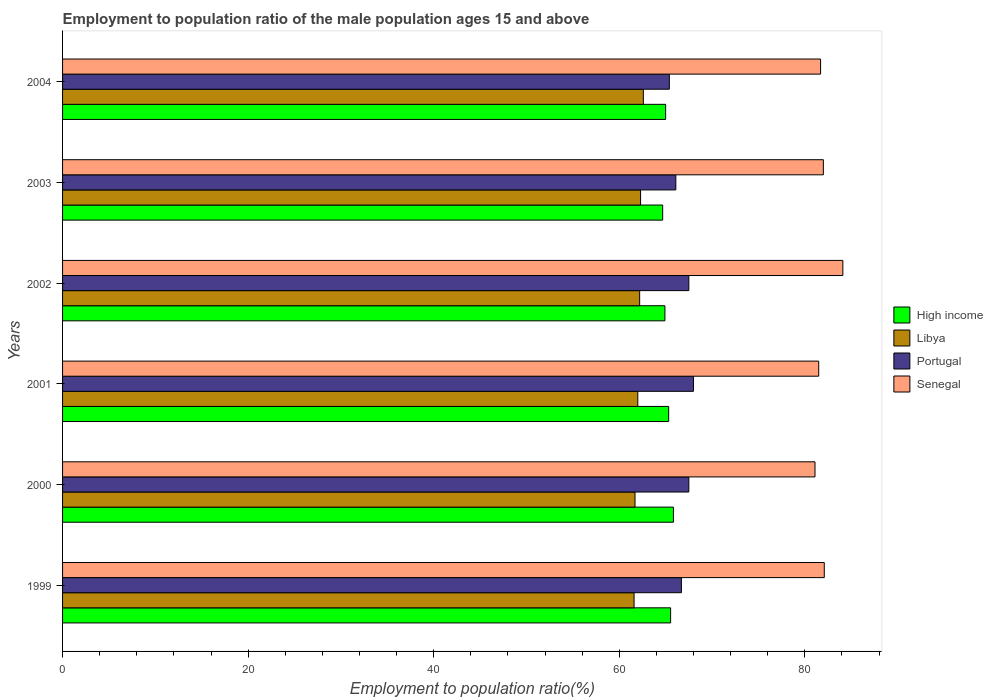How many different coloured bars are there?
Provide a succinct answer. 4. Are the number of bars on each tick of the Y-axis equal?
Make the answer very short. Yes. How many bars are there on the 3rd tick from the top?
Keep it short and to the point. 4. What is the label of the 6th group of bars from the top?
Your response must be concise. 1999. In how many cases, is the number of bars for a given year not equal to the number of legend labels?
Keep it short and to the point. 0. What is the employment to population ratio in Senegal in 2000?
Provide a short and direct response. 81.1. Across all years, what is the maximum employment to population ratio in High income?
Offer a very short reply. 65.84. Across all years, what is the minimum employment to population ratio in Senegal?
Give a very brief answer. 81.1. In which year was the employment to population ratio in Portugal maximum?
Give a very brief answer. 2001. In which year was the employment to population ratio in Libya minimum?
Your response must be concise. 1999. What is the total employment to population ratio in Libya in the graph?
Provide a short and direct response. 372.4. What is the difference between the employment to population ratio in High income in 2002 and that in 2003?
Keep it short and to the point. 0.24. What is the difference between the employment to population ratio in Senegal in 1999 and the employment to population ratio in Portugal in 2003?
Keep it short and to the point. 16. What is the average employment to population ratio in Senegal per year?
Give a very brief answer. 82.08. In the year 2001, what is the difference between the employment to population ratio in Portugal and employment to population ratio in High income?
Provide a short and direct response. 2.67. What is the ratio of the employment to population ratio in High income in 1999 to that in 2002?
Provide a succinct answer. 1.01. Is the difference between the employment to population ratio in Portugal in 1999 and 2001 greater than the difference between the employment to population ratio in High income in 1999 and 2001?
Make the answer very short. No. What is the difference between the highest and the second highest employment to population ratio in Libya?
Your answer should be compact. 0.3. What is the difference between the highest and the lowest employment to population ratio in Portugal?
Make the answer very short. 2.6. Is the sum of the employment to population ratio in Portugal in 2001 and 2004 greater than the maximum employment to population ratio in Libya across all years?
Your answer should be compact. Yes. Is it the case that in every year, the sum of the employment to population ratio in High income and employment to population ratio in Portugal is greater than the sum of employment to population ratio in Libya and employment to population ratio in Senegal?
Ensure brevity in your answer.  No. Are all the bars in the graph horizontal?
Keep it short and to the point. Yes. How many years are there in the graph?
Your answer should be very brief. 6. What is the difference between two consecutive major ticks on the X-axis?
Provide a short and direct response. 20. Does the graph contain grids?
Keep it short and to the point. No. How many legend labels are there?
Provide a succinct answer. 4. What is the title of the graph?
Offer a terse response. Employment to population ratio of the male population ages 15 and above. Does "Niger" appear as one of the legend labels in the graph?
Give a very brief answer. No. What is the label or title of the X-axis?
Offer a very short reply. Employment to population ratio(%). What is the label or title of the Y-axis?
Your response must be concise. Years. What is the Employment to population ratio(%) in High income in 1999?
Provide a short and direct response. 65.54. What is the Employment to population ratio(%) in Libya in 1999?
Your response must be concise. 61.6. What is the Employment to population ratio(%) in Portugal in 1999?
Your response must be concise. 66.7. What is the Employment to population ratio(%) in Senegal in 1999?
Offer a very short reply. 82.1. What is the Employment to population ratio(%) of High income in 2000?
Provide a short and direct response. 65.84. What is the Employment to population ratio(%) in Libya in 2000?
Offer a very short reply. 61.7. What is the Employment to population ratio(%) in Portugal in 2000?
Provide a succinct answer. 67.5. What is the Employment to population ratio(%) in Senegal in 2000?
Give a very brief answer. 81.1. What is the Employment to population ratio(%) of High income in 2001?
Your answer should be compact. 65.33. What is the Employment to population ratio(%) in Libya in 2001?
Keep it short and to the point. 62. What is the Employment to population ratio(%) of Senegal in 2001?
Keep it short and to the point. 81.5. What is the Employment to population ratio(%) in High income in 2002?
Your answer should be very brief. 64.92. What is the Employment to population ratio(%) in Libya in 2002?
Your response must be concise. 62.2. What is the Employment to population ratio(%) in Portugal in 2002?
Give a very brief answer. 67.5. What is the Employment to population ratio(%) in Senegal in 2002?
Offer a very short reply. 84.1. What is the Employment to population ratio(%) of High income in 2003?
Give a very brief answer. 64.68. What is the Employment to population ratio(%) of Libya in 2003?
Keep it short and to the point. 62.3. What is the Employment to population ratio(%) in Portugal in 2003?
Offer a very short reply. 66.1. What is the Employment to population ratio(%) of Senegal in 2003?
Give a very brief answer. 82. What is the Employment to population ratio(%) of High income in 2004?
Your answer should be very brief. 65. What is the Employment to population ratio(%) in Libya in 2004?
Your answer should be very brief. 62.6. What is the Employment to population ratio(%) in Portugal in 2004?
Provide a short and direct response. 65.4. What is the Employment to population ratio(%) in Senegal in 2004?
Give a very brief answer. 81.7. Across all years, what is the maximum Employment to population ratio(%) in High income?
Your response must be concise. 65.84. Across all years, what is the maximum Employment to population ratio(%) of Libya?
Provide a short and direct response. 62.6. Across all years, what is the maximum Employment to population ratio(%) of Senegal?
Your answer should be compact. 84.1. Across all years, what is the minimum Employment to population ratio(%) of High income?
Ensure brevity in your answer.  64.68. Across all years, what is the minimum Employment to population ratio(%) of Libya?
Your answer should be compact. 61.6. Across all years, what is the minimum Employment to population ratio(%) of Portugal?
Provide a succinct answer. 65.4. Across all years, what is the minimum Employment to population ratio(%) in Senegal?
Provide a short and direct response. 81.1. What is the total Employment to population ratio(%) of High income in the graph?
Keep it short and to the point. 391.31. What is the total Employment to population ratio(%) in Libya in the graph?
Keep it short and to the point. 372.4. What is the total Employment to population ratio(%) of Portugal in the graph?
Offer a very short reply. 401.2. What is the total Employment to population ratio(%) in Senegal in the graph?
Your answer should be very brief. 492.5. What is the difference between the Employment to population ratio(%) in High income in 1999 and that in 2000?
Keep it short and to the point. -0.3. What is the difference between the Employment to population ratio(%) of Portugal in 1999 and that in 2000?
Offer a terse response. -0.8. What is the difference between the Employment to population ratio(%) in High income in 1999 and that in 2001?
Your answer should be compact. 0.21. What is the difference between the Employment to population ratio(%) in High income in 1999 and that in 2002?
Provide a short and direct response. 0.61. What is the difference between the Employment to population ratio(%) in Portugal in 1999 and that in 2002?
Ensure brevity in your answer.  -0.8. What is the difference between the Employment to population ratio(%) of High income in 1999 and that in 2003?
Your response must be concise. 0.86. What is the difference between the Employment to population ratio(%) of Libya in 1999 and that in 2003?
Give a very brief answer. -0.7. What is the difference between the Employment to population ratio(%) of Senegal in 1999 and that in 2003?
Your answer should be very brief. 0.1. What is the difference between the Employment to population ratio(%) in High income in 1999 and that in 2004?
Provide a succinct answer. 0.54. What is the difference between the Employment to population ratio(%) in Portugal in 1999 and that in 2004?
Ensure brevity in your answer.  1.3. What is the difference between the Employment to population ratio(%) in High income in 2000 and that in 2001?
Offer a very short reply. 0.51. What is the difference between the Employment to population ratio(%) of Portugal in 2000 and that in 2001?
Offer a very short reply. -0.5. What is the difference between the Employment to population ratio(%) of Senegal in 2000 and that in 2001?
Keep it short and to the point. -0.4. What is the difference between the Employment to population ratio(%) of High income in 2000 and that in 2002?
Offer a terse response. 0.92. What is the difference between the Employment to population ratio(%) of High income in 2000 and that in 2003?
Provide a succinct answer. 1.16. What is the difference between the Employment to population ratio(%) in Senegal in 2000 and that in 2003?
Ensure brevity in your answer.  -0.9. What is the difference between the Employment to population ratio(%) in High income in 2000 and that in 2004?
Give a very brief answer. 0.84. What is the difference between the Employment to population ratio(%) of Senegal in 2000 and that in 2004?
Your answer should be very brief. -0.6. What is the difference between the Employment to population ratio(%) in High income in 2001 and that in 2002?
Offer a very short reply. 0.4. What is the difference between the Employment to population ratio(%) in Senegal in 2001 and that in 2002?
Your answer should be compact. -2.6. What is the difference between the Employment to population ratio(%) of High income in 2001 and that in 2003?
Keep it short and to the point. 0.65. What is the difference between the Employment to population ratio(%) in Libya in 2001 and that in 2003?
Make the answer very short. -0.3. What is the difference between the Employment to population ratio(%) of High income in 2001 and that in 2004?
Offer a terse response. 0.33. What is the difference between the Employment to population ratio(%) of Portugal in 2001 and that in 2004?
Offer a very short reply. 2.6. What is the difference between the Employment to population ratio(%) of High income in 2002 and that in 2003?
Your response must be concise. 0.24. What is the difference between the Employment to population ratio(%) in Libya in 2002 and that in 2003?
Keep it short and to the point. -0.1. What is the difference between the Employment to population ratio(%) in Senegal in 2002 and that in 2003?
Your answer should be compact. 2.1. What is the difference between the Employment to population ratio(%) in High income in 2002 and that in 2004?
Your answer should be very brief. -0.08. What is the difference between the Employment to population ratio(%) in Libya in 2002 and that in 2004?
Give a very brief answer. -0.4. What is the difference between the Employment to population ratio(%) of Senegal in 2002 and that in 2004?
Give a very brief answer. 2.4. What is the difference between the Employment to population ratio(%) in High income in 2003 and that in 2004?
Your answer should be very brief. -0.32. What is the difference between the Employment to population ratio(%) of Portugal in 2003 and that in 2004?
Provide a short and direct response. 0.7. What is the difference between the Employment to population ratio(%) in Senegal in 2003 and that in 2004?
Offer a terse response. 0.3. What is the difference between the Employment to population ratio(%) of High income in 1999 and the Employment to population ratio(%) of Libya in 2000?
Ensure brevity in your answer.  3.84. What is the difference between the Employment to population ratio(%) of High income in 1999 and the Employment to population ratio(%) of Portugal in 2000?
Give a very brief answer. -1.96. What is the difference between the Employment to population ratio(%) in High income in 1999 and the Employment to population ratio(%) in Senegal in 2000?
Make the answer very short. -15.56. What is the difference between the Employment to population ratio(%) in Libya in 1999 and the Employment to population ratio(%) in Senegal in 2000?
Your answer should be compact. -19.5. What is the difference between the Employment to population ratio(%) of Portugal in 1999 and the Employment to population ratio(%) of Senegal in 2000?
Your answer should be compact. -14.4. What is the difference between the Employment to population ratio(%) in High income in 1999 and the Employment to population ratio(%) in Libya in 2001?
Provide a succinct answer. 3.54. What is the difference between the Employment to population ratio(%) in High income in 1999 and the Employment to population ratio(%) in Portugal in 2001?
Your answer should be compact. -2.46. What is the difference between the Employment to population ratio(%) of High income in 1999 and the Employment to population ratio(%) of Senegal in 2001?
Provide a succinct answer. -15.96. What is the difference between the Employment to population ratio(%) in Libya in 1999 and the Employment to population ratio(%) in Senegal in 2001?
Give a very brief answer. -19.9. What is the difference between the Employment to population ratio(%) in Portugal in 1999 and the Employment to population ratio(%) in Senegal in 2001?
Keep it short and to the point. -14.8. What is the difference between the Employment to population ratio(%) in High income in 1999 and the Employment to population ratio(%) in Libya in 2002?
Provide a short and direct response. 3.34. What is the difference between the Employment to population ratio(%) of High income in 1999 and the Employment to population ratio(%) of Portugal in 2002?
Offer a very short reply. -1.96. What is the difference between the Employment to population ratio(%) in High income in 1999 and the Employment to population ratio(%) in Senegal in 2002?
Offer a very short reply. -18.56. What is the difference between the Employment to population ratio(%) of Libya in 1999 and the Employment to population ratio(%) of Portugal in 2002?
Offer a very short reply. -5.9. What is the difference between the Employment to population ratio(%) of Libya in 1999 and the Employment to population ratio(%) of Senegal in 2002?
Keep it short and to the point. -22.5. What is the difference between the Employment to population ratio(%) of Portugal in 1999 and the Employment to population ratio(%) of Senegal in 2002?
Keep it short and to the point. -17.4. What is the difference between the Employment to population ratio(%) of High income in 1999 and the Employment to population ratio(%) of Libya in 2003?
Your response must be concise. 3.24. What is the difference between the Employment to population ratio(%) of High income in 1999 and the Employment to population ratio(%) of Portugal in 2003?
Ensure brevity in your answer.  -0.56. What is the difference between the Employment to population ratio(%) of High income in 1999 and the Employment to population ratio(%) of Senegal in 2003?
Keep it short and to the point. -16.46. What is the difference between the Employment to population ratio(%) of Libya in 1999 and the Employment to population ratio(%) of Senegal in 2003?
Give a very brief answer. -20.4. What is the difference between the Employment to population ratio(%) in Portugal in 1999 and the Employment to population ratio(%) in Senegal in 2003?
Offer a very short reply. -15.3. What is the difference between the Employment to population ratio(%) in High income in 1999 and the Employment to population ratio(%) in Libya in 2004?
Ensure brevity in your answer.  2.94. What is the difference between the Employment to population ratio(%) of High income in 1999 and the Employment to population ratio(%) of Portugal in 2004?
Provide a short and direct response. 0.14. What is the difference between the Employment to population ratio(%) in High income in 1999 and the Employment to population ratio(%) in Senegal in 2004?
Give a very brief answer. -16.16. What is the difference between the Employment to population ratio(%) of Libya in 1999 and the Employment to population ratio(%) of Portugal in 2004?
Offer a terse response. -3.8. What is the difference between the Employment to population ratio(%) in Libya in 1999 and the Employment to population ratio(%) in Senegal in 2004?
Make the answer very short. -20.1. What is the difference between the Employment to population ratio(%) of Portugal in 1999 and the Employment to population ratio(%) of Senegal in 2004?
Make the answer very short. -15. What is the difference between the Employment to population ratio(%) of High income in 2000 and the Employment to population ratio(%) of Libya in 2001?
Make the answer very short. 3.84. What is the difference between the Employment to population ratio(%) in High income in 2000 and the Employment to population ratio(%) in Portugal in 2001?
Offer a terse response. -2.16. What is the difference between the Employment to population ratio(%) of High income in 2000 and the Employment to population ratio(%) of Senegal in 2001?
Provide a succinct answer. -15.66. What is the difference between the Employment to population ratio(%) of Libya in 2000 and the Employment to population ratio(%) of Portugal in 2001?
Your answer should be compact. -6.3. What is the difference between the Employment to population ratio(%) in Libya in 2000 and the Employment to population ratio(%) in Senegal in 2001?
Provide a succinct answer. -19.8. What is the difference between the Employment to population ratio(%) of Portugal in 2000 and the Employment to population ratio(%) of Senegal in 2001?
Give a very brief answer. -14. What is the difference between the Employment to population ratio(%) of High income in 2000 and the Employment to population ratio(%) of Libya in 2002?
Your answer should be very brief. 3.64. What is the difference between the Employment to population ratio(%) in High income in 2000 and the Employment to population ratio(%) in Portugal in 2002?
Give a very brief answer. -1.66. What is the difference between the Employment to population ratio(%) in High income in 2000 and the Employment to population ratio(%) in Senegal in 2002?
Make the answer very short. -18.26. What is the difference between the Employment to population ratio(%) of Libya in 2000 and the Employment to population ratio(%) of Senegal in 2002?
Offer a very short reply. -22.4. What is the difference between the Employment to population ratio(%) of Portugal in 2000 and the Employment to population ratio(%) of Senegal in 2002?
Provide a succinct answer. -16.6. What is the difference between the Employment to population ratio(%) in High income in 2000 and the Employment to population ratio(%) in Libya in 2003?
Provide a succinct answer. 3.54. What is the difference between the Employment to population ratio(%) of High income in 2000 and the Employment to population ratio(%) of Portugal in 2003?
Your answer should be very brief. -0.26. What is the difference between the Employment to population ratio(%) in High income in 2000 and the Employment to population ratio(%) in Senegal in 2003?
Offer a terse response. -16.16. What is the difference between the Employment to population ratio(%) in Libya in 2000 and the Employment to population ratio(%) in Portugal in 2003?
Provide a short and direct response. -4.4. What is the difference between the Employment to population ratio(%) in Libya in 2000 and the Employment to population ratio(%) in Senegal in 2003?
Give a very brief answer. -20.3. What is the difference between the Employment to population ratio(%) of Portugal in 2000 and the Employment to population ratio(%) of Senegal in 2003?
Keep it short and to the point. -14.5. What is the difference between the Employment to population ratio(%) in High income in 2000 and the Employment to population ratio(%) in Libya in 2004?
Your response must be concise. 3.24. What is the difference between the Employment to population ratio(%) of High income in 2000 and the Employment to population ratio(%) of Portugal in 2004?
Give a very brief answer. 0.44. What is the difference between the Employment to population ratio(%) in High income in 2000 and the Employment to population ratio(%) in Senegal in 2004?
Provide a succinct answer. -15.86. What is the difference between the Employment to population ratio(%) of Portugal in 2000 and the Employment to population ratio(%) of Senegal in 2004?
Keep it short and to the point. -14.2. What is the difference between the Employment to population ratio(%) in High income in 2001 and the Employment to population ratio(%) in Libya in 2002?
Offer a terse response. 3.13. What is the difference between the Employment to population ratio(%) of High income in 2001 and the Employment to population ratio(%) of Portugal in 2002?
Ensure brevity in your answer.  -2.17. What is the difference between the Employment to population ratio(%) in High income in 2001 and the Employment to population ratio(%) in Senegal in 2002?
Your answer should be compact. -18.77. What is the difference between the Employment to population ratio(%) of Libya in 2001 and the Employment to population ratio(%) of Portugal in 2002?
Provide a succinct answer. -5.5. What is the difference between the Employment to population ratio(%) of Libya in 2001 and the Employment to population ratio(%) of Senegal in 2002?
Provide a succinct answer. -22.1. What is the difference between the Employment to population ratio(%) of Portugal in 2001 and the Employment to population ratio(%) of Senegal in 2002?
Your response must be concise. -16.1. What is the difference between the Employment to population ratio(%) in High income in 2001 and the Employment to population ratio(%) in Libya in 2003?
Ensure brevity in your answer.  3.03. What is the difference between the Employment to population ratio(%) in High income in 2001 and the Employment to population ratio(%) in Portugal in 2003?
Offer a terse response. -0.77. What is the difference between the Employment to population ratio(%) in High income in 2001 and the Employment to population ratio(%) in Senegal in 2003?
Provide a short and direct response. -16.67. What is the difference between the Employment to population ratio(%) in Libya in 2001 and the Employment to population ratio(%) in Senegal in 2003?
Your answer should be compact. -20. What is the difference between the Employment to population ratio(%) of Portugal in 2001 and the Employment to population ratio(%) of Senegal in 2003?
Ensure brevity in your answer.  -14. What is the difference between the Employment to population ratio(%) in High income in 2001 and the Employment to population ratio(%) in Libya in 2004?
Keep it short and to the point. 2.73. What is the difference between the Employment to population ratio(%) of High income in 2001 and the Employment to population ratio(%) of Portugal in 2004?
Offer a terse response. -0.07. What is the difference between the Employment to population ratio(%) of High income in 2001 and the Employment to population ratio(%) of Senegal in 2004?
Give a very brief answer. -16.37. What is the difference between the Employment to population ratio(%) in Libya in 2001 and the Employment to population ratio(%) in Senegal in 2004?
Ensure brevity in your answer.  -19.7. What is the difference between the Employment to population ratio(%) of Portugal in 2001 and the Employment to population ratio(%) of Senegal in 2004?
Offer a terse response. -13.7. What is the difference between the Employment to population ratio(%) in High income in 2002 and the Employment to population ratio(%) in Libya in 2003?
Offer a very short reply. 2.62. What is the difference between the Employment to population ratio(%) in High income in 2002 and the Employment to population ratio(%) in Portugal in 2003?
Provide a short and direct response. -1.18. What is the difference between the Employment to population ratio(%) of High income in 2002 and the Employment to population ratio(%) of Senegal in 2003?
Give a very brief answer. -17.08. What is the difference between the Employment to population ratio(%) of Libya in 2002 and the Employment to population ratio(%) of Senegal in 2003?
Your answer should be compact. -19.8. What is the difference between the Employment to population ratio(%) of Portugal in 2002 and the Employment to population ratio(%) of Senegal in 2003?
Give a very brief answer. -14.5. What is the difference between the Employment to population ratio(%) in High income in 2002 and the Employment to population ratio(%) in Libya in 2004?
Ensure brevity in your answer.  2.32. What is the difference between the Employment to population ratio(%) of High income in 2002 and the Employment to population ratio(%) of Portugal in 2004?
Your response must be concise. -0.48. What is the difference between the Employment to population ratio(%) of High income in 2002 and the Employment to population ratio(%) of Senegal in 2004?
Provide a succinct answer. -16.78. What is the difference between the Employment to population ratio(%) of Libya in 2002 and the Employment to population ratio(%) of Portugal in 2004?
Offer a terse response. -3.2. What is the difference between the Employment to population ratio(%) of Libya in 2002 and the Employment to population ratio(%) of Senegal in 2004?
Your answer should be compact. -19.5. What is the difference between the Employment to population ratio(%) in Portugal in 2002 and the Employment to population ratio(%) in Senegal in 2004?
Provide a short and direct response. -14.2. What is the difference between the Employment to population ratio(%) of High income in 2003 and the Employment to population ratio(%) of Libya in 2004?
Offer a terse response. 2.08. What is the difference between the Employment to population ratio(%) in High income in 2003 and the Employment to population ratio(%) in Portugal in 2004?
Your response must be concise. -0.72. What is the difference between the Employment to population ratio(%) of High income in 2003 and the Employment to population ratio(%) of Senegal in 2004?
Your answer should be very brief. -17.02. What is the difference between the Employment to population ratio(%) in Libya in 2003 and the Employment to population ratio(%) in Senegal in 2004?
Provide a short and direct response. -19.4. What is the difference between the Employment to population ratio(%) of Portugal in 2003 and the Employment to population ratio(%) of Senegal in 2004?
Provide a succinct answer. -15.6. What is the average Employment to population ratio(%) of High income per year?
Offer a very short reply. 65.22. What is the average Employment to population ratio(%) of Libya per year?
Provide a short and direct response. 62.07. What is the average Employment to population ratio(%) of Portugal per year?
Keep it short and to the point. 66.87. What is the average Employment to population ratio(%) in Senegal per year?
Offer a very short reply. 82.08. In the year 1999, what is the difference between the Employment to population ratio(%) of High income and Employment to population ratio(%) of Libya?
Keep it short and to the point. 3.94. In the year 1999, what is the difference between the Employment to population ratio(%) of High income and Employment to population ratio(%) of Portugal?
Offer a very short reply. -1.16. In the year 1999, what is the difference between the Employment to population ratio(%) of High income and Employment to population ratio(%) of Senegal?
Offer a terse response. -16.56. In the year 1999, what is the difference between the Employment to population ratio(%) of Libya and Employment to population ratio(%) of Portugal?
Make the answer very short. -5.1. In the year 1999, what is the difference between the Employment to population ratio(%) in Libya and Employment to population ratio(%) in Senegal?
Offer a terse response. -20.5. In the year 1999, what is the difference between the Employment to population ratio(%) in Portugal and Employment to population ratio(%) in Senegal?
Your answer should be very brief. -15.4. In the year 2000, what is the difference between the Employment to population ratio(%) of High income and Employment to population ratio(%) of Libya?
Provide a short and direct response. 4.14. In the year 2000, what is the difference between the Employment to population ratio(%) of High income and Employment to population ratio(%) of Portugal?
Provide a succinct answer. -1.66. In the year 2000, what is the difference between the Employment to population ratio(%) of High income and Employment to population ratio(%) of Senegal?
Provide a short and direct response. -15.26. In the year 2000, what is the difference between the Employment to population ratio(%) of Libya and Employment to population ratio(%) of Portugal?
Offer a very short reply. -5.8. In the year 2000, what is the difference between the Employment to population ratio(%) of Libya and Employment to population ratio(%) of Senegal?
Give a very brief answer. -19.4. In the year 2001, what is the difference between the Employment to population ratio(%) in High income and Employment to population ratio(%) in Libya?
Ensure brevity in your answer.  3.33. In the year 2001, what is the difference between the Employment to population ratio(%) of High income and Employment to population ratio(%) of Portugal?
Give a very brief answer. -2.67. In the year 2001, what is the difference between the Employment to population ratio(%) in High income and Employment to population ratio(%) in Senegal?
Offer a terse response. -16.17. In the year 2001, what is the difference between the Employment to population ratio(%) of Libya and Employment to population ratio(%) of Portugal?
Your answer should be compact. -6. In the year 2001, what is the difference between the Employment to population ratio(%) of Libya and Employment to population ratio(%) of Senegal?
Your answer should be compact. -19.5. In the year 2001, what is the difference between the Employment to population ratio(%) of Portugal and Employment to population ratio(%) of Senegal?
Keep it short and to the point. -13.5. In the year 2002, what is the difference between the Employment to population ratio(%) of High income and Employment to population ratio(%) of Libya?
Your answer should be compact. 2.72. In the year 2002, what is the difference between the Employment to population ratio(%) in High income and Employment to population ratio(%) in Portugal?
Provide a succinct answer. -2.58. In the year 2002, what is the difference between the Employment to population ratio(%) of High income and Employment to population ratio(%) of Senegal?
Offer a terse response. -19.18. In the year 2002, what is the difference between the Employment to population ratio(%) of Libya and Employment to population ratio(%) of Portugal?
Make the answer very short. -5.3. In the year 2002, what is the difference between the Employment to population ratio(%) in Libya and Employment to population ratio(%) in Senegal?
Your answer should be compact. -21.9. In the year 2002, what is the difference between the Employment to population ratio(%) in Portugal and Employment to population ratio(%) in Senegal?
Make the answer very short. -16.6. In the year 2003, what is the difference between the Employment to population ratio(%) of High income and Employment to population ratio(%) of Libya?
Offer a very short reply. 2.38. In the year 2003, what is the difference between the Employment to population ratio(%) in High income and Employment to population ratio(%) in Portugal?
Give a very brief answer. -1.42. In the year 2003, what is the difference between the Employment to population ratio(%) in High income and Employment to population ratio(%) in Senegal?
Ensure brevity in your answer.  -17.32. In the year 2003, what is the difference between the Employment to population ratio(%) in Libya and Employment to population ratio(%) in Senegal?
Your answer should be very brief. -19.7. In the year 2003, what is the difference between the Employment to population ratio(%) of Portugal and Employment to population ratio(%) of Senegal?
Make the answer very short. -15.9. In the year 2004, what is the difference between the Employment to population ratio(%) in High income and Employment to population ratio(%) in Libya?
Keep it short and to the point. 2.4. In the year 2004, what is the difference between the Employment to population ratio(%) of High income and Employment to population ratio(%) of Portugal?
Make the answer very short. -0.4. In the year 2004, what is the difference between the Employment to population ratio(%) of High income and Employment to population ratio(%) of Senegal?
Ensure brevity in your answer.  -16.7. In the year 2004, what is the difference between the Employment to population ratio(%) in Libya and Employment to population ratio(%) in Portugal?
Ensure brevity in your answer.  -2.8. In the year 2004, what is the difference between the Employment to population ratio(%) in Libya and Employment to population ratio(%) in Senegal?
Offer a terse response. -19.1. In the year 2004, what is the difference between the Employment to population ratio(%) of Portugal and Employment to population ratio(%) of Senegal?
Ensure brevity in your answer.  -16.3. What is the ratio of the Employment to population ratio(%) of High income in 1999 to that in 2000?
Make the answer very short. 1. What is the ratio of the Employment to population ratio(%) in Libya in 1999 to that in 2000?
Make the answer very short. 1. What is the ratio of the Employment to population ratio(%) in Senegal in 1999 to that in 2000?
Keep it short and to the point. 1.01. What is the ratio of the Employment to population ratio(%) of Portugal in 1999 to that in 2001?
Ensure brevity in your answer.  0.98. What is the ratio of the Employment to population ratio(%) in Senegal in 1999 to that in 2001?
Keep it short and to the point. 1.01. What is the ratio of the Employment to population ratio(%) of High income in 1999 to that in 2002?
Your answer should be very brief. 1.01. What is the ratio of the Employment to population ratio(%) in Libya in 1999 to that in 2002?
Provide a succinct answer. 0.99. What is the ratio of the Employment to population ratio(%) in Senegal in 1999 to that in 2002?
Offer a very short reply. 0.98. What is the ratio of the Employment to population ratio(%) of High income in 1999 to that in 2003?
Provide a short and direct response. 1.01. What is the ratio of the Employment to population ratio(%) of Libya in 1999 to that in 2003?
Your answer should be compact. 0.99. What is the ratio of the Employment to population ratio(%) in Portugal in 1999 to that in 2003?
Keep it short and to the point. 1.01. What is the ratio of the Employment to population ratio(%) of High income in 1999 to that in 2004?
Offer a very short reply. 1.01. What is the ratio of the Employment to population ratio(%) of Portugal in 1999 to that in 2004?
Ensure brevity in your answer.  1.02. What is the ratio of the Employment to population ratio(%) in Senegal in 1999 to that in 2004?
Ensure brevity in your answer.  1. What is the ratio of the Employment to population ratio(%) of Portugal in 2000 to that in 2001?
Make the answer very short. 0.99. What is the ratio of the Employment to population ratio(%) of High income in 2000 to that in 2002?
Your answer should be very brief. 1.01. What is the ratio of the Employment to population ratio(%) of Libya in 2000 to that in 2002?
Ensure brevity in your answer.  0.99. What is the ratio of the Employment to population ratio(%) of Portugal in 2000 to that in 2002?
Keep it short and to the point. 1. What is the ratio of the Employment to population ratio(%) in Senegal in 2000 to that in 2002?
Provide a short and direct response. 0.96. What is the ratio of the Employment to population ratio(%) in High income in 2000 to that in 2003?
Your answer should be compact. 1.02. What is the ratio of the Employment to population ratio(%) in Libya in 2000 to that in 2003?
Give a very brief answer. 0.99. What is the ratio of the Employment to population ratio(%) in Portugal in 2000 to that in 2003?
Give a very brief answer. 1.02. What is the ratio of the Employment to population ratio(%) of High income in 2000 to that in 2004?
Provide a short and direct response. 1.01. What is the ratio of the Employment to population ratio(%) in Libya in 2000 to that in 2004?
Provide a short and direct response. 0.99. What is the ratio of the Employment to population ratio(%) in Portugal in 2000 to that in 2004?
Make the answer very short. 1.03. What is the ratio of the Employment to population ratio(%) of Portugal in 2001 to that in 2002?
Your response must be concise. 1.01. What is the ratio of the Employment to population ratio(%) in Senegal in 2001 to that in 2002?
Your answer should be very brief. 0.97. What is the ratio of the Employment to population ratio(%) in Portugal in 2001 to that in 2003?
Your answer should be very brief. 1.03. What is the ratio of the Employment to population ratio(%) in Senegal in 2001 to that in 2003?
Make the answer very short. 0.99. What is the ratio of the Employment to population ratio(%) in Portugal in 2001 to that in 2004?
Offer a very short reply. 1.04. What is the ratio of the Employment to population ratio(%) of Senegal in 2001 to that in 2004?
Provide a short and direct response. 1. What is the ratio of the Employment to population ratio(%) in High income in 2002 to that in 2003?
Your answer should be very brief. 1. What is the ratio of the Employment to population ratio(%) in Libya in 2002 to that in 2003?
Your response must be concise. 1. What is the ratio of the Employment to population ratio(%) in Portugal in 2002 to that in 2003?
Give a very brief answer. 1.02. What is the ratio of the Employment to population ratio(%) in Senegal in 2002 to that in 2003?
Make the answer very short. 1.03. What is the ratio of the Employment to population ratio(%) in High income in 2002 to that in 2004?
Ensure brevity in your answer.  1. What is the ratio of the Employment to population ratio(%) of Portugal in 2002 to that in 2004?
Offer a terse response. 1.03. What is the ratio of the Employment to population ratio(%) of Senegal in 2002 to that in 2004?
Provide a succinct answer. 1.03. What is the ratio of the Employment to population ratio(%) of Libya in 2003 to that in 2004?
Your response must be concise. 1. What is the ratio of the Employment to population ratio(%) in Portugal in 2003 to that in 2004?
Give a very brief answer. 1.01. What is the difference between the highest and the second highest Employment to population ratio(%) of High income?
Provide a short and direct response. 0.3. What is the difference between the highest and the second highest Employment to population ratio(%) of Libya?
Give a very brief answer. 0.3. What is the difference between the highest and the second highest Employment to population ratio(%) in Portugal?
Offer a very short reply. 0.5. What is the difference between the highest and the second highest Employment to population ratio(%) in Senegal?
Give a very brief answer. 2. What is the difference between the highest and the lowest Employment to population ratio(%) in High income?
Give a very brief answer. 1.16. What is the difference between the highest and the lowest Employment to population ratio(%) of Portugal?
Ensure brevity in your answer.  2.6. 